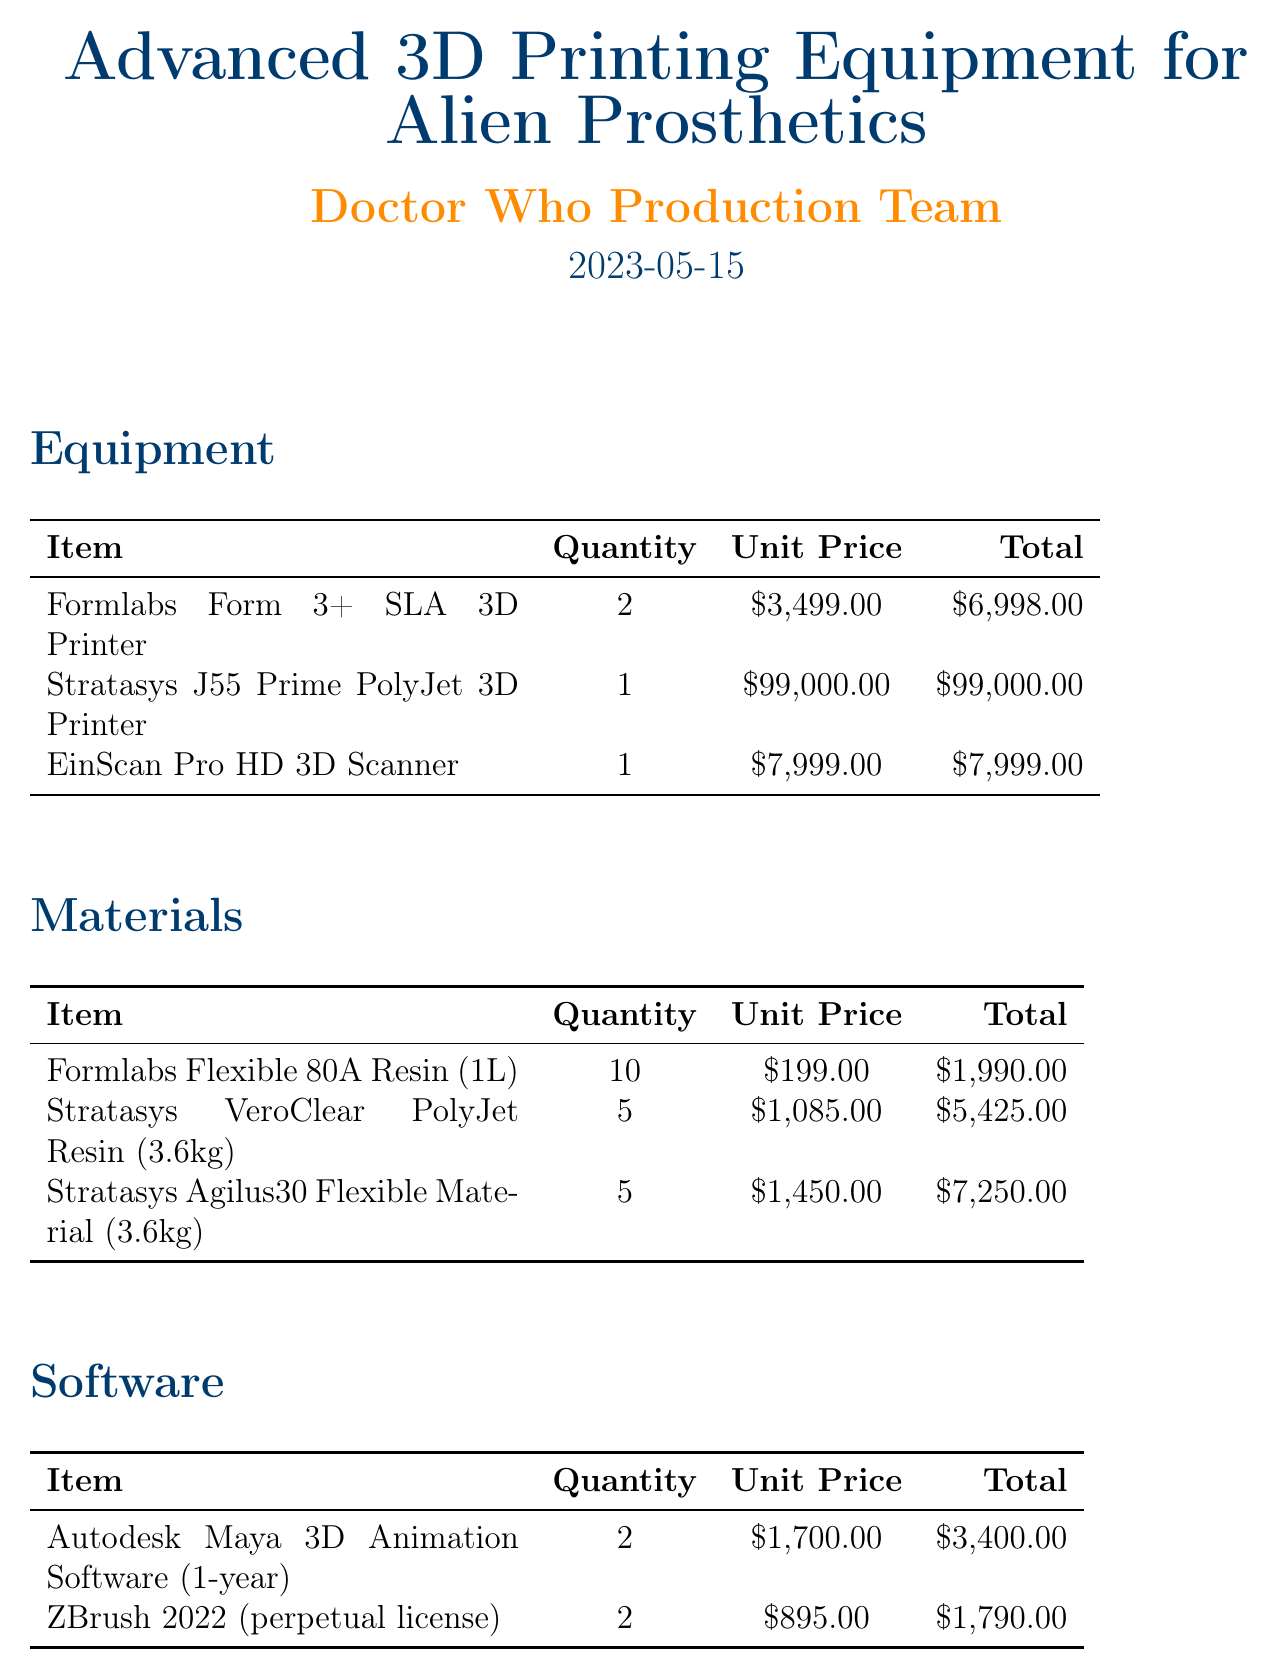What is the total cost of the equipment? The total cost of the equipment is obtained by adding the total prices for each item listed under the Equipment section: $6,998.00 + $99,000.00 + $7,999.00 = $113,997.00.
Answer: $113,997.00 How many EinScan Pro HD 3D Scanners are included? The document states that there is 1 EinScan Pro HD 3D Scanner included in the Equipment section.
Answer: 1 What is the unit price of the Stratasys J55 Prime PolyJet 3D Printer? The document lists the unit price of the Stratasys J55 Prime PolyJet 3D Printer as $99,000.00.
Answer: $99,000.00 What is the total cost for the maintenance contract? The total cost for the maintenance contract, which is listed under Additional Costs, is $7,500.00.
Answer: $7,500.00 How many units of Formlabs Flexible 80A Resin are being purchased? The document states there are 10 units of Formlabs Flexible 80A Resin being purchased in the Materials section.
Answer: 10 What software has a perpetual license? The document lists ZBrush 2022 as the software that has a perpetual license, which is inferred from its description in the Software section.
Answer: ZBrush 2022 What is the quantity of the Stratasys Agilus30 Flexible Material? The document indicates that 5 units of Stratasys Agilus30 Flexible Material are being purchased.
Answer: 5 How much is allocated for staff training? The document states that $5,000.00 is allocated for staff training under Additional Costs.
Answer: $5,000.00 What is the total amount for materials? The total amount for materials is calculated by summing the total prices of each item in the Materials section: $1,990.00 + $5,425.00 + $7,250.00 = $14,665.00.
Answer: $14,665.00 